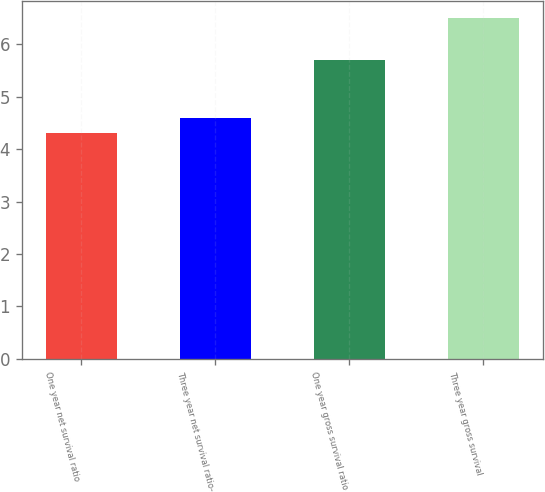Convert chart to OTSL. <chart><loc_0><loc_0><loc_500><loc_500><bar_chart><fcel>One year net survival ratio<fcel>Three year net survival ratio-<fcel>One year gross survival ratio<fcel>Three year gross survival<nl><fcel>4.3<fcel>4.6<fcel>5.7<fcel>6.5<nl></chart> 